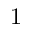<formula> <loc_0><loc_0><loc_500><loc_500>\ k _ { 1 }</formula> 